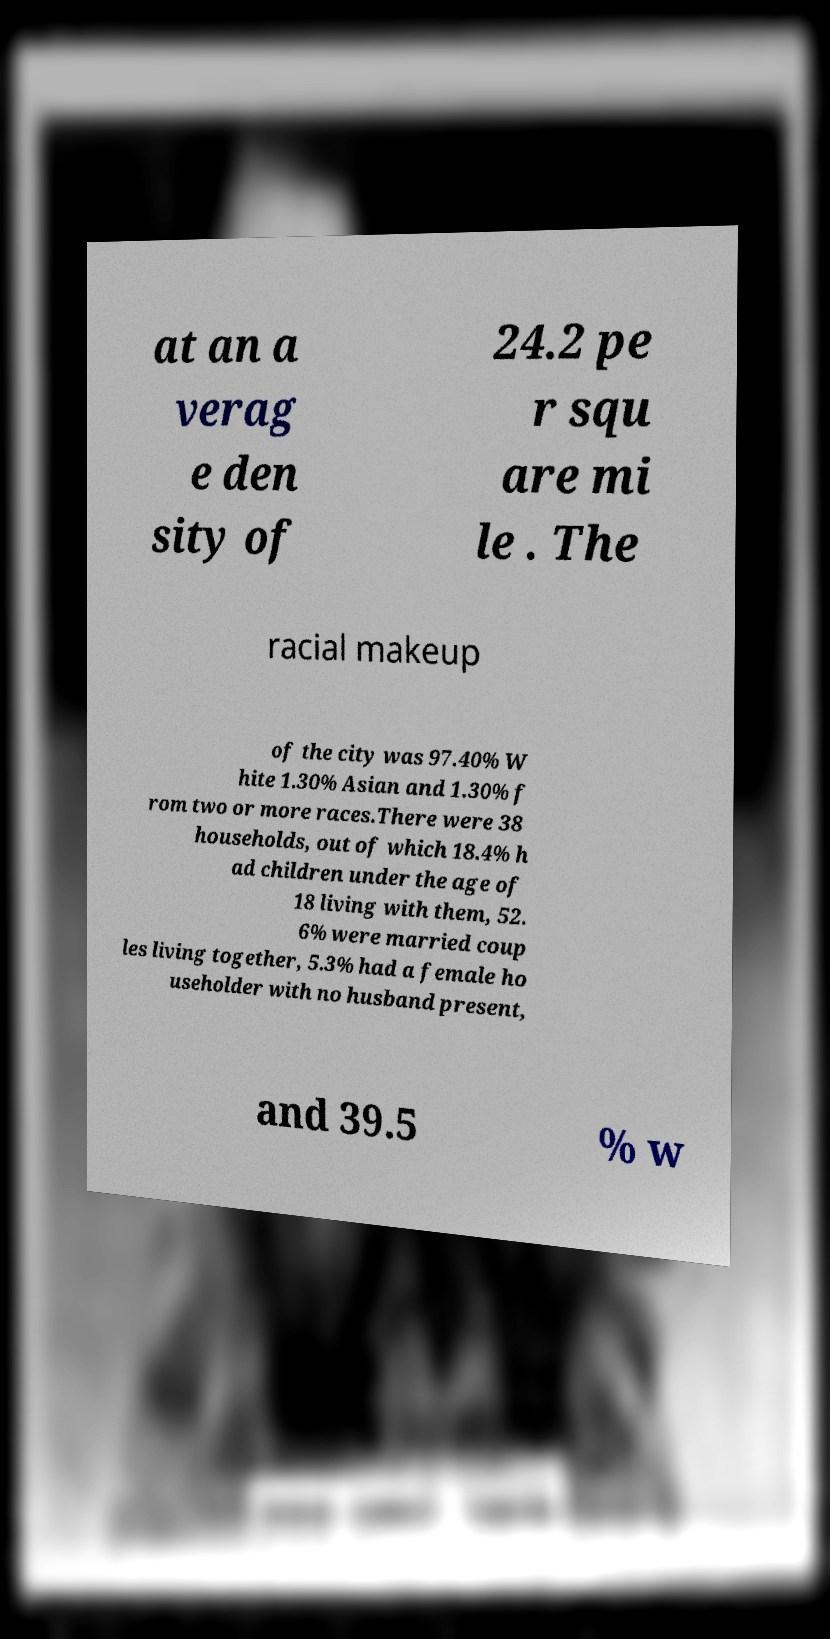What messages or text are displayed in this image? I need them in a readable, typed format. at an a verag e den sity of 24.2 pe r squ are mi le . The racial makeup of the city was 97.40% W hite 1.30% Asian and 1.30% f rom two or more races.There were 38 households, out of which 18.4% h ad children under the age of 18 living with them, 52. 6% were married coup les living together, 5.3% had a female ho useholder with no husband present, and 39.5 % w 